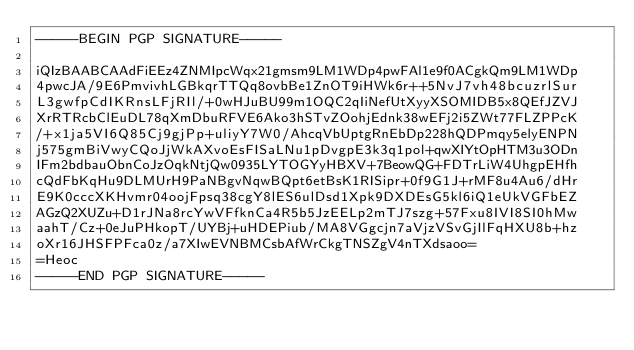<code> <loc_0><loc_0><loc_500><loc_500><_SML_>-----BEGIN PGP SIGNATURE-----

iQIzBAABCAAdFiEEz4ZNMIpcWqx21gmsm9LM1WDp4pwFAl1e9f0ACgkQm9LM1WDp
4pwcJA/9E6PmvivhLGBkqrTTQq8ovbBe1ZnOT9iHWk6r++5NvJ7vh48bcuzrlSur
L3gwfpCdIKRnsLFjRIl/+0wHJuBU99m1OQC2qIiNefUtXyyXSOMIDB5x8QEfJZVJ
XrRTRcbClEuDL78qXmDbuRFVE6Ako3hSTvZOohjEdnk38wEFj2i5ZWt77FLZPPcK
/+x1ja5VI6Q85Cj9gjPp+uliyY7W0/AhcqVbUptgRnEbDp228hQDPmqy5elyENPN
j575gmBiVwyCQoJjWkAXvoEsFISaLNu1pDvgpE3k3q1pol+qwXIYtOpHTM3u3ODn
IFm2bdbauObnCoJzOqkNtjQw0935LYTOGYyHBXV+7BeowQG+FDTrLiW4UhgpEHfh
cQdFbKqHu9DLMUrH9PaNBgvNqwBQpt6etBsK1RISipr+0f9G1J+rMF8u4Au6/dHr
E9K0cccXKHvmr04oojFpsq38cgY8lES6ulDsd1Xpk9DXDEsG5kl6iQ1eUkVGFbEZ
AGzQ2XUZu+D1rJNa8rcYwVFfknCa4R5b5JzEELp2mTJ7szg+57Fxu8IVI8SI0hMw
aahT/Cz+0eJuPHkopT/UYBj+uHDEPiub/MA8VGgcjn7aVjzVSvGjIlFqHXU8b+hz
oXr16JHSFPFca0z/a7XIwEVNBMCsbAfWrCkgTNSZgV4nTXdsaoo=
=Heoc
-----END PGP SIGNATURE-----
</code> 